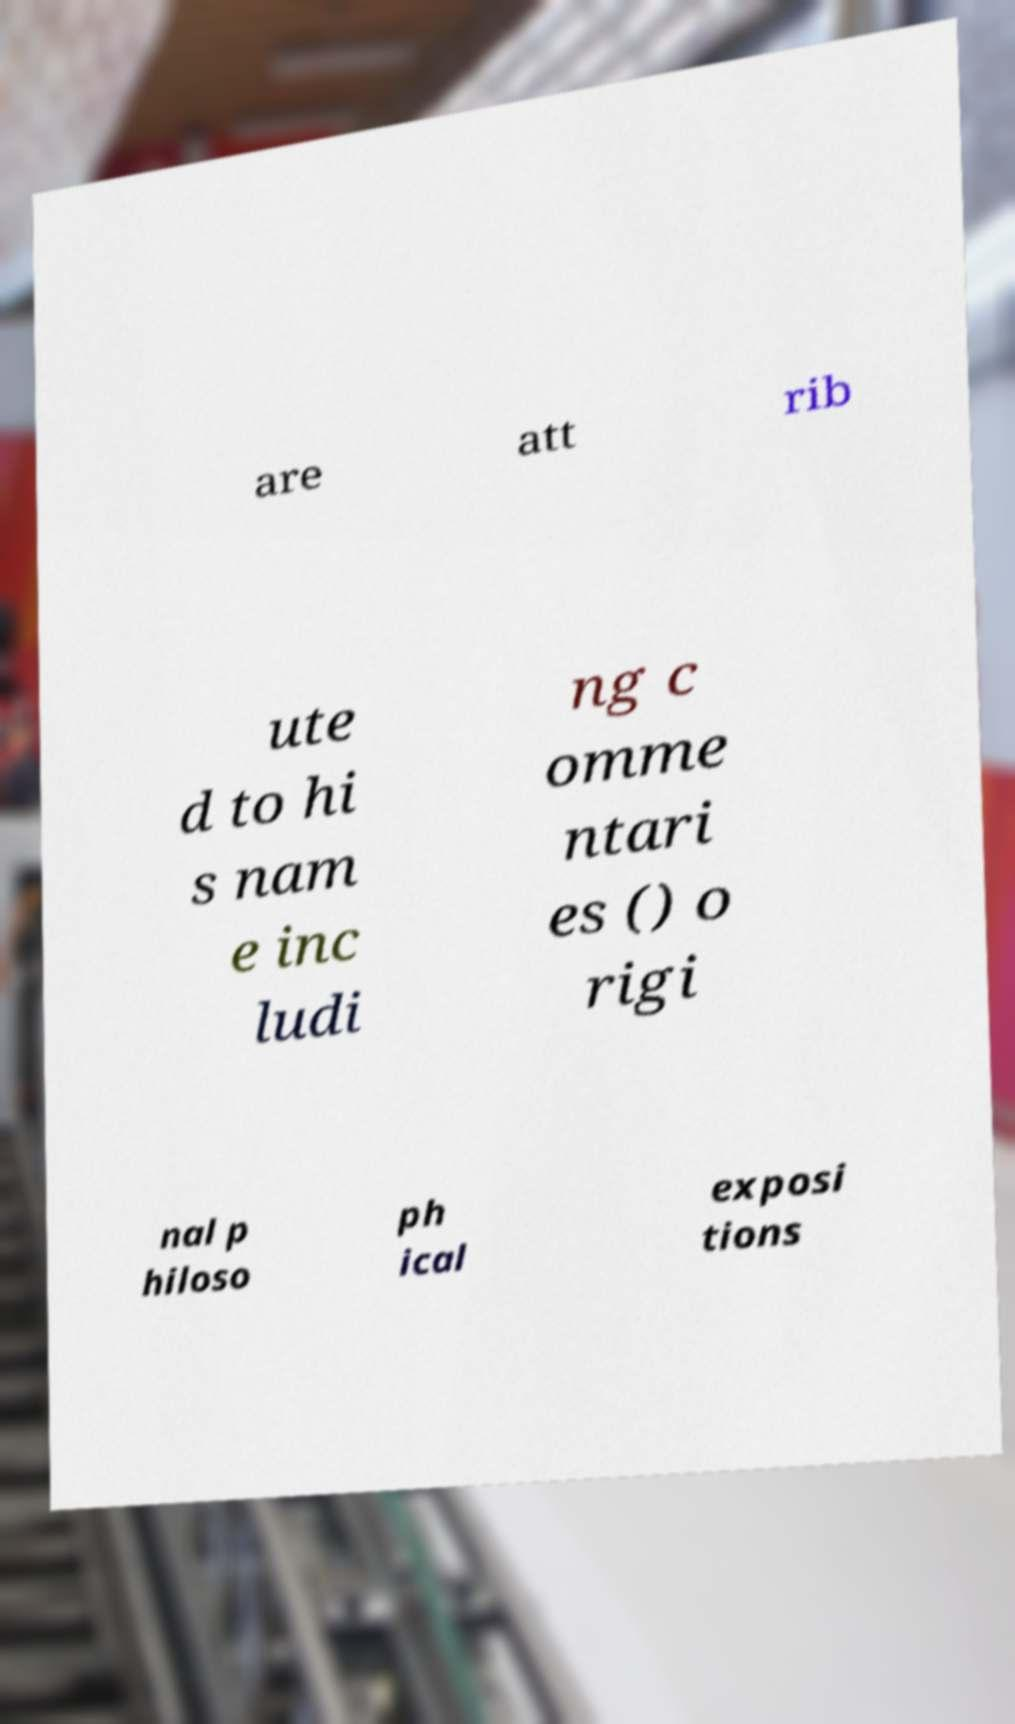Please read and relay the text visible in this image. What does it say? are att rib ute d to hi s nam e inc ludi ng c omme ntari es () o rigi nal p hiloso ph ical exposi tions 